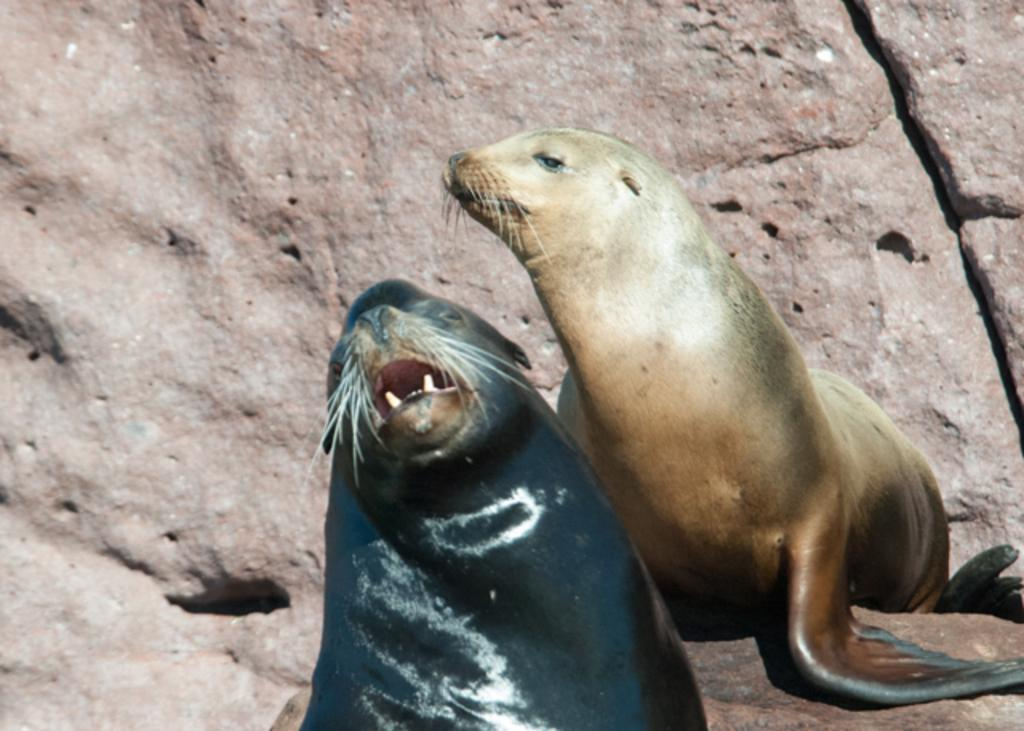What animals are present in the image? There are two seals in the picture. Where are the seals located? The seals are sitting on a rock. Can you describe the color of the seals? The seal in the front is dark in color. What type of discussion is happening between the seals in the image? There is no indication of a discussion between the seals in the image, as they are simply sitting on a rock. 